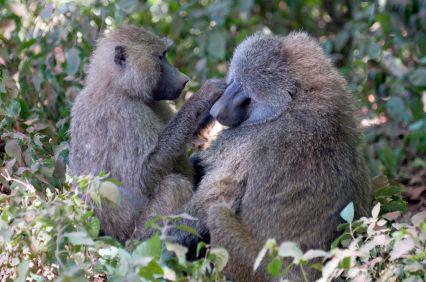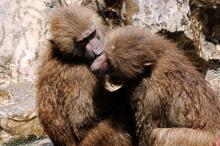The first image is the image on the left, the second image is the image on the right. Examine the images to the left and right. Is the description "Each image shows exactly two baboons interacting, and the left image shows one baboon grooming the fur of a baboon with its head lowered and paws down." accurate? Answer yes or no. Yes. The first image is the image on the left, the second image is the image on the right. Considering the images on both sides, is "In the image on the left, there are only 2 monkeys and they have their heads turned in the same direction." valid? Answer yes or no. No. 